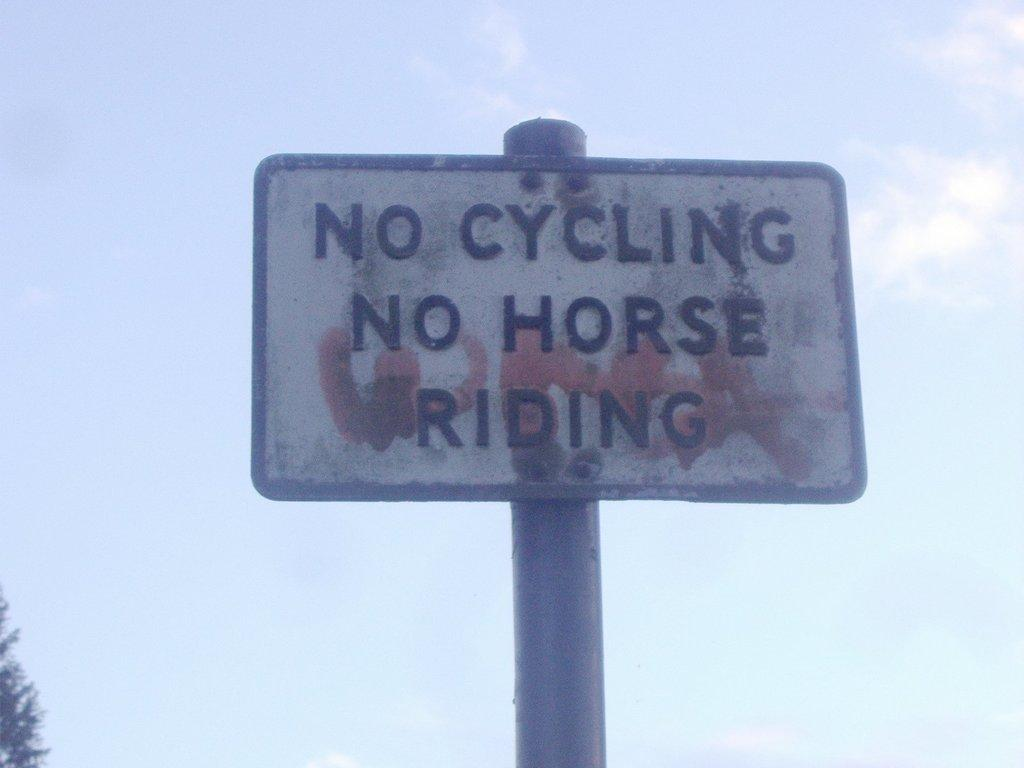<image>
Summarize the visual content of the image. a no cycling sign that is on a pole 